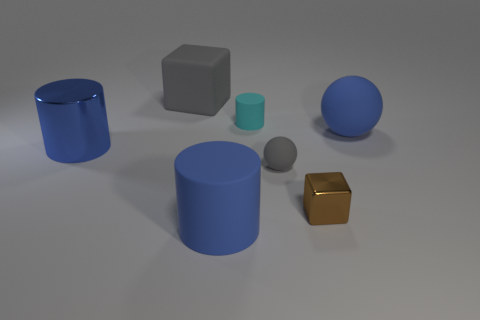Subtract all yellow balls. How many blue cylinders are left? 2 Subtract all big blue cylinders. How many cylinders are left? 1 Add 1 small blue matte cubes. How many objects exist? 8 Subtract all cylinders. How many objects are left? 4 Subtract all big cyan objects. Subtract all metallic cylinders. How many objects are left? 6 Add 5 large objects. How many large objects are left? 9 Add 4 large brown rubber cylinders. How many large brown rubber cylinders exist? 4 Subtract 0 cyan cubes. How many objects are left? 7 